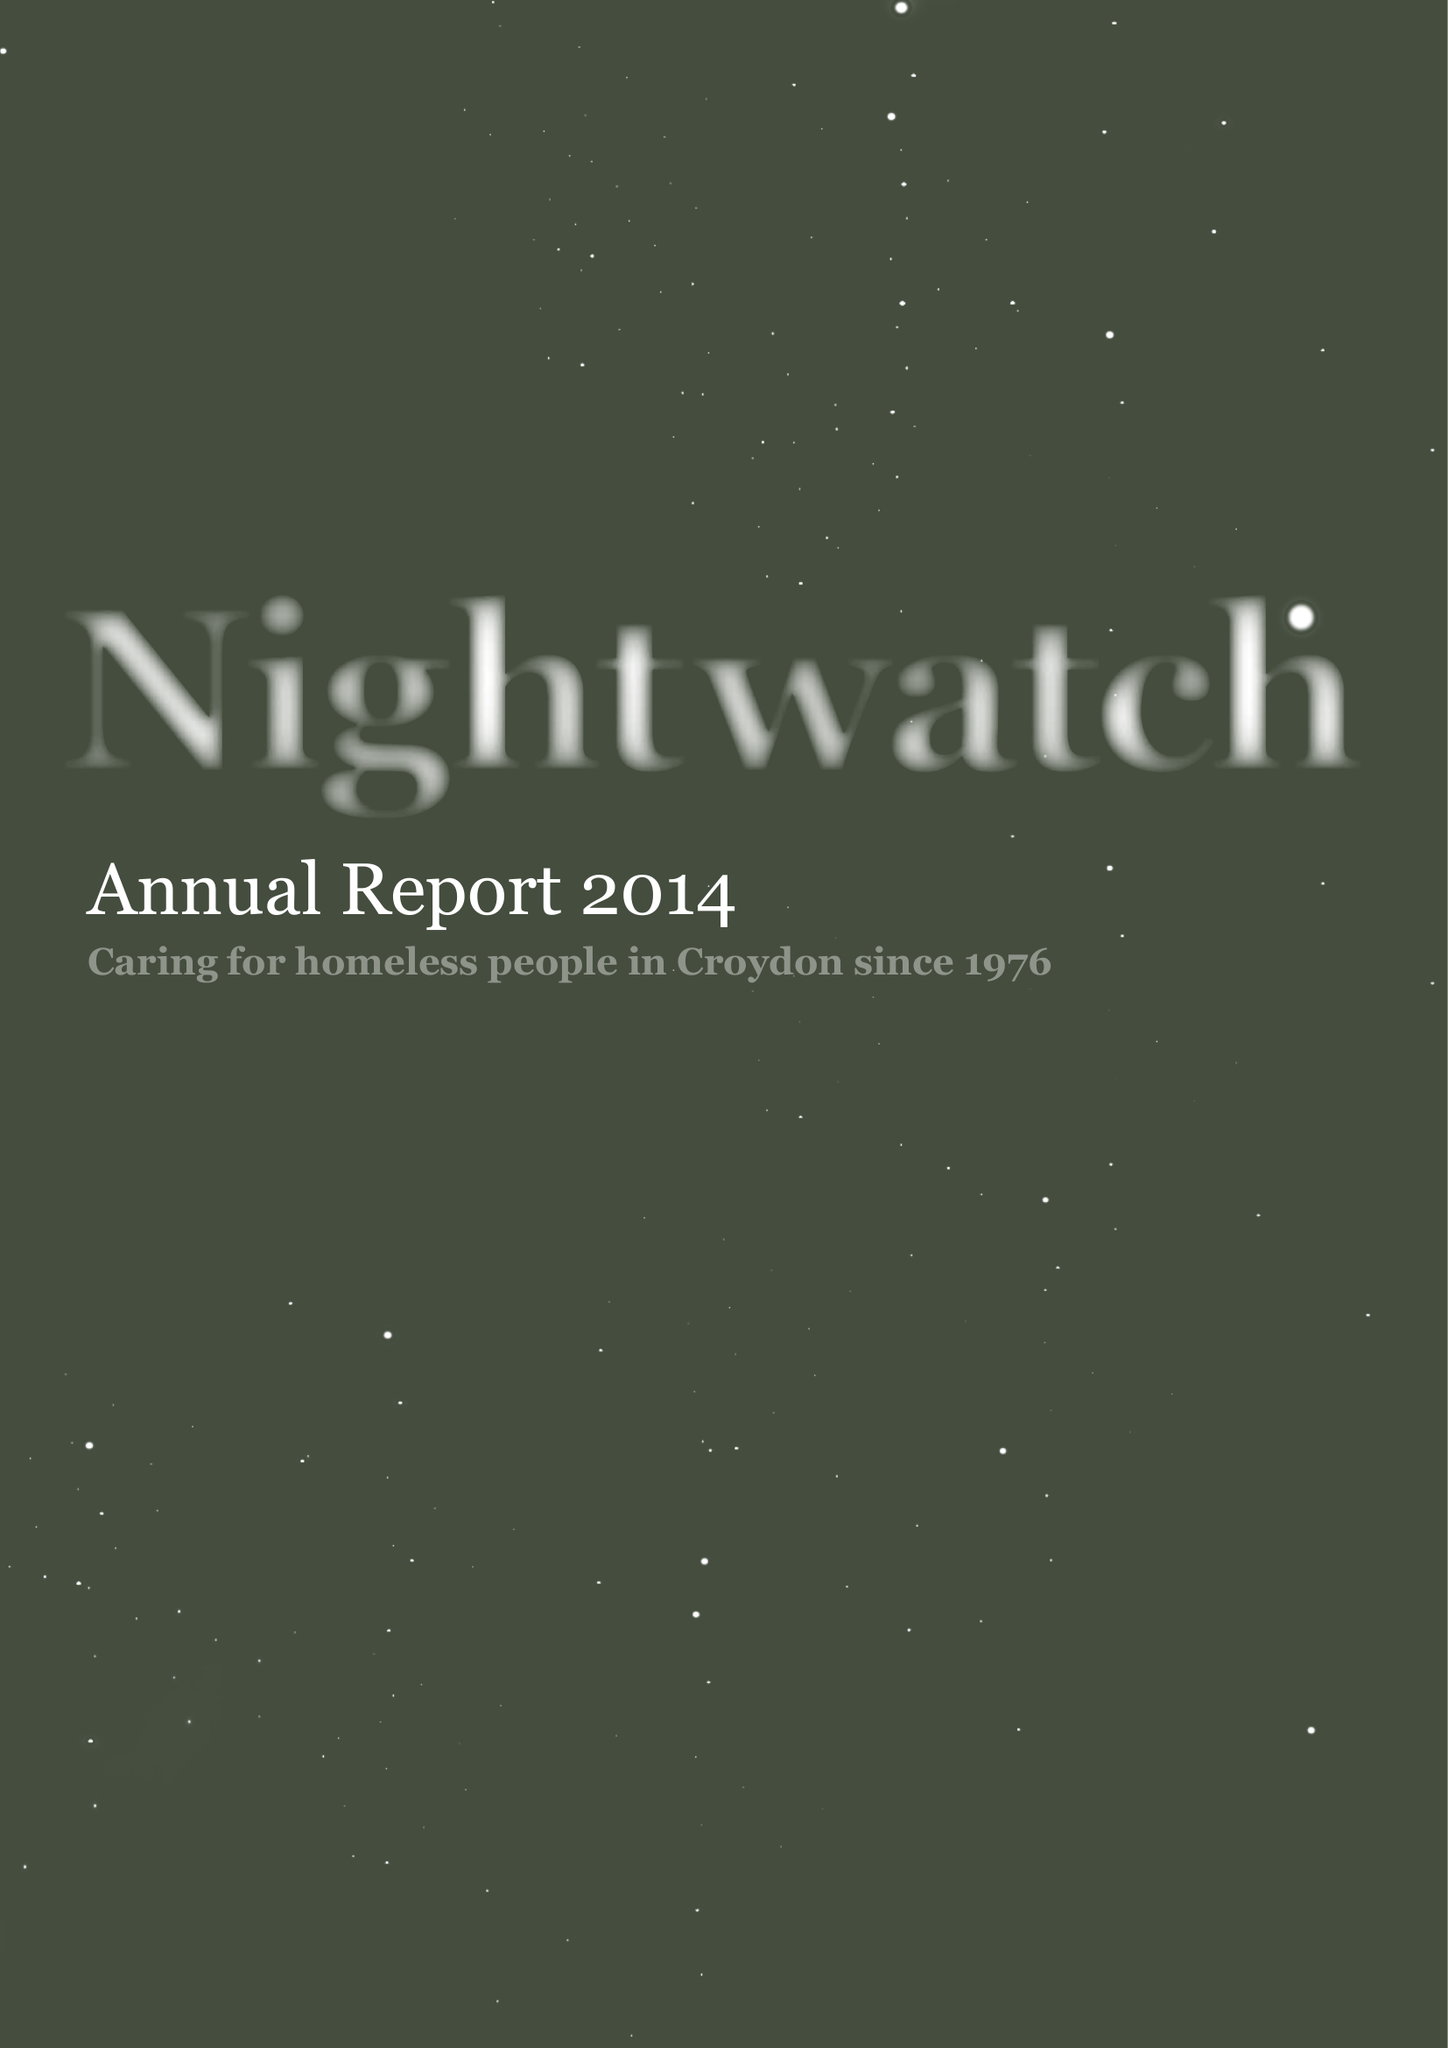What is the value for the spending_annually_in_british_pounds?
Answer the question using a single word or phrase. 35741.00 